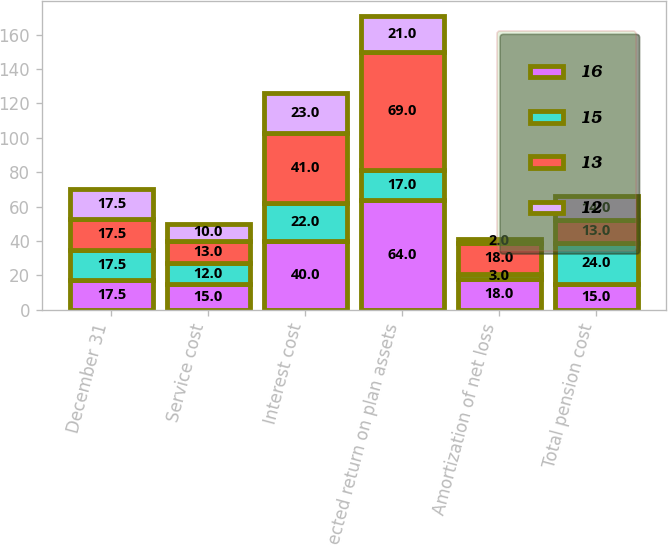Convert chart. <chart><loc_0><loc_0><loc_500><loc_500><stacked_bar_chart><ecel><fcel>December 31<fcel>Service cost<fcel>Interest cost<fcel>Expected return on plan assets<fcel>Amortization of net loss<fcel>Total pension cost<nl><fcel>16<fcel>17.5<fcel>15<fcel>40<fcel>64<fcel>18<fcel>15<nl><fcel>15<fcel>17.5<fcel>12<fcel>22<fcel>17<fcel>3<fcel>24<nl><fcel>13<fcel>17.5<fcel>13<fcel>41<fcel>69<fcel>18<fcel>13<nl><fcel>12<fcel>17.5<fcel>10<fcel>23<fcel>21<fcel>2<fcel>14<nl></chart> 